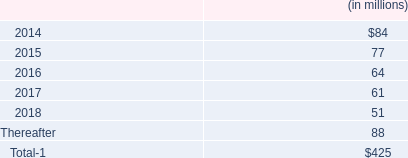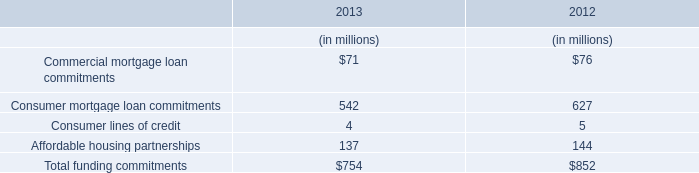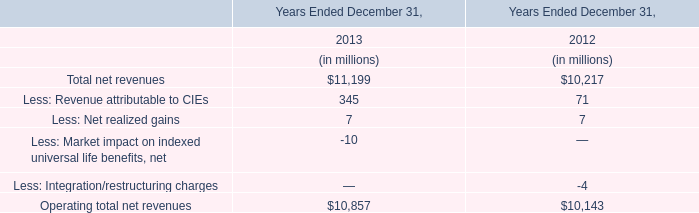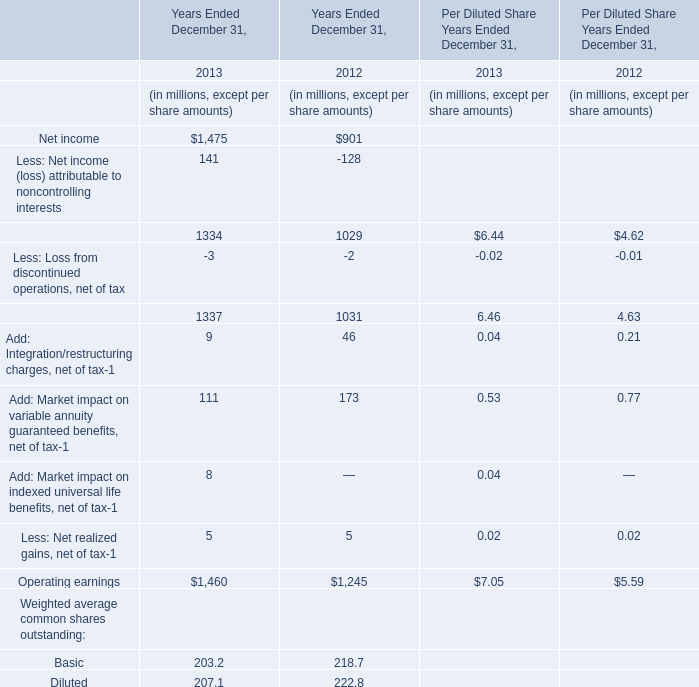What's the average of Total net revenues in 2013 and 2012? (in million) 
Computations: ((11199 + 10217) / 2)
Answer: 10708.0. 